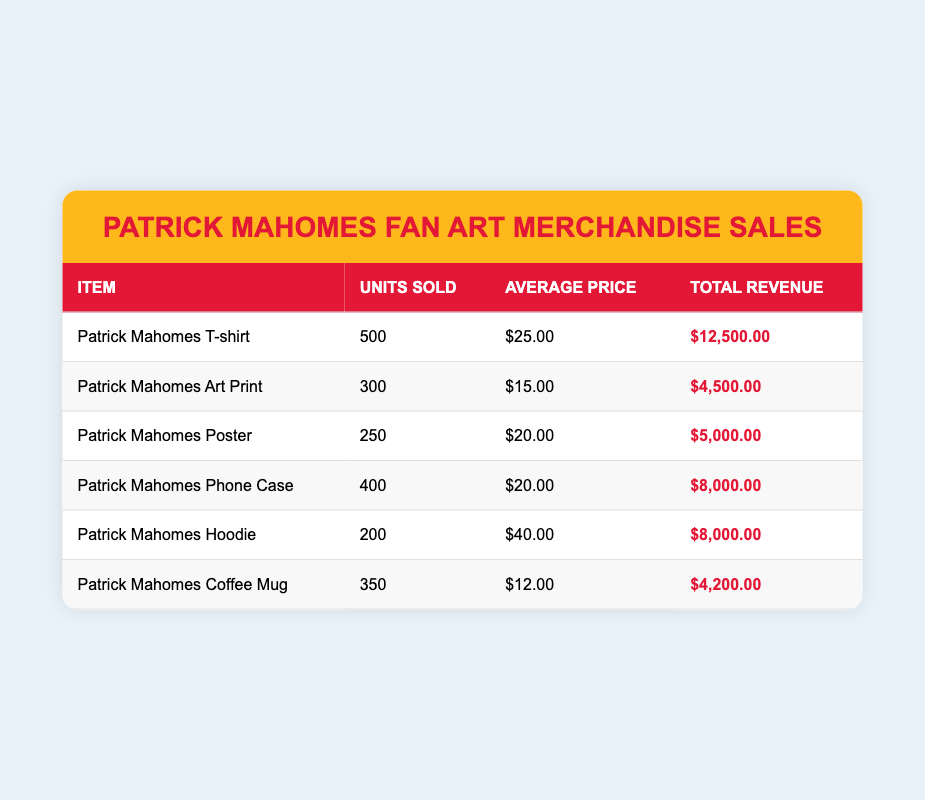What item had the highest units sold? The highest units sold is found by comparing the 'Units Sold' column. The Patrick Mahomes T-shirt sold 500 units, which is the maximum in the table.
Answer: Patrick Mahomes T-shirt How much total revenue was generated from the Patrick Mahomes Art Print? The total revenue for the Patrick Mahomes Art Print is listed directly in the 'Total Revenue' column, which shows $4,500.00.
Answer: $4,500.00 What is the average price of the Patrick Mahomes Phone Case? The average price for the Patrick Mahomes Phone Case is available in the 'Average Price' column, which shows $20.00.
Answer: $20.00 Which item had a total revenue greater than $8,000.00? To find items with total revenue greater than $8,000.00, we look at the 'Total Revenue' column. The Patrick Mahomes T-shirt ($12,500.00) and both the Phone Case and Hoodie ($8,000.00) are noted, but only the T-shirt exceeds $8,000.00.
Answer: Patrick Mahomes T-shirt What is the total revenue generated from all merchandise sales? To find the total revenue from all merchandise, we sum the values in the 'Total Revenue' column: $12,500.00 + $4,500.00 + $5,000.00 + $8,000.00 + $8,000.00 + $4,200.00 = $42,200.00.
Answer: $42,200.00 Did the Patrick Mahomes Hoodie sell more units than the Patrick Mahomes Poster? To compare, we check the 'Units Sold' for the Hoodie and the Poster. The Hoodie sold 200 units, while the Poster sold 250 units. Since 200 is not greater than 250, the statement is false.
Answer: No What is the percentage of total revenue contributed by the Patrick Mahomes T-shirt? First, we identify the total revenue, which is $42,200.00, then find the T-shirt revenue, which is $12,500.00. The percentage contribution is calculated as ($12,500.00 / $42,200.00) * 100 = 29.6%.
Answer: 29.6% How many more units of the Patrick Mahomes Phone Case were sold compared to the Hoodie? The Phone Case sold 400 units and the Hoodie sold 200 units. The difference is 400 - 200 = 200 units more for the Phone Case.
Answer: 200 units Which merchandise had the lowest total revenue? Looking at the 'Total Revenue' column, the lowest value is for the Patrick Mahomes Coffee Mug at $4,200.00.
Answer: Patrick Mahomes Coffee Mug 